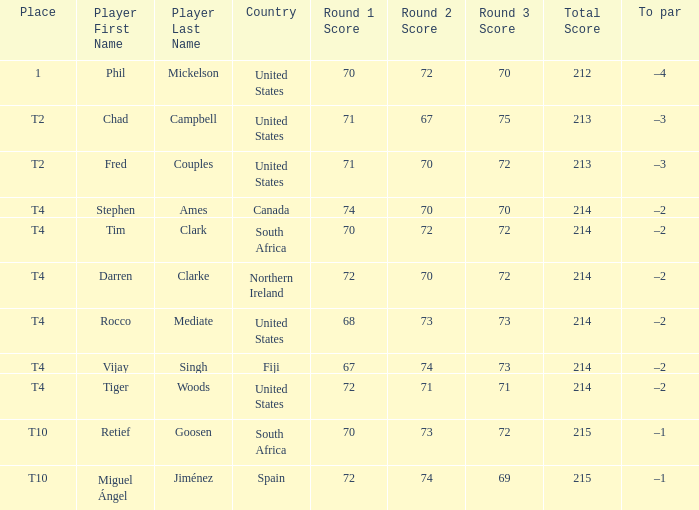Where is Fred Couples from? United States. 